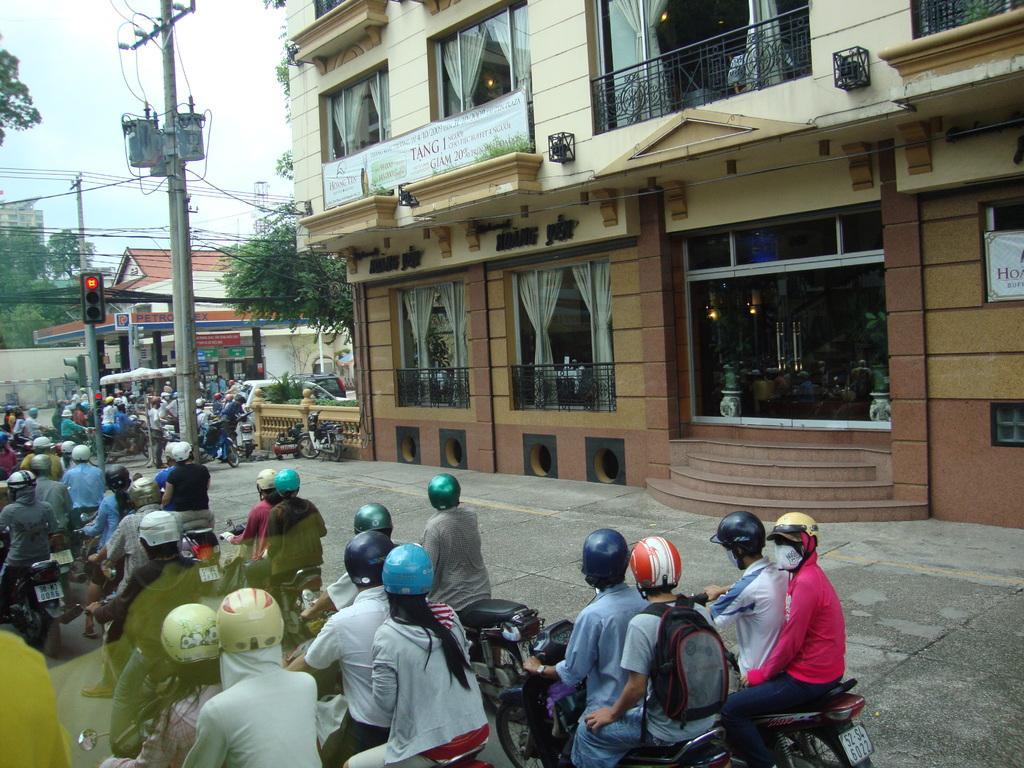In one or two sentences, can you explain what this image depicts? The image is taken on the road. On the left side of the image we can see people sitting on the bikes and there are poles. On the right there is a building. In the background there are trees, wires and sky. 